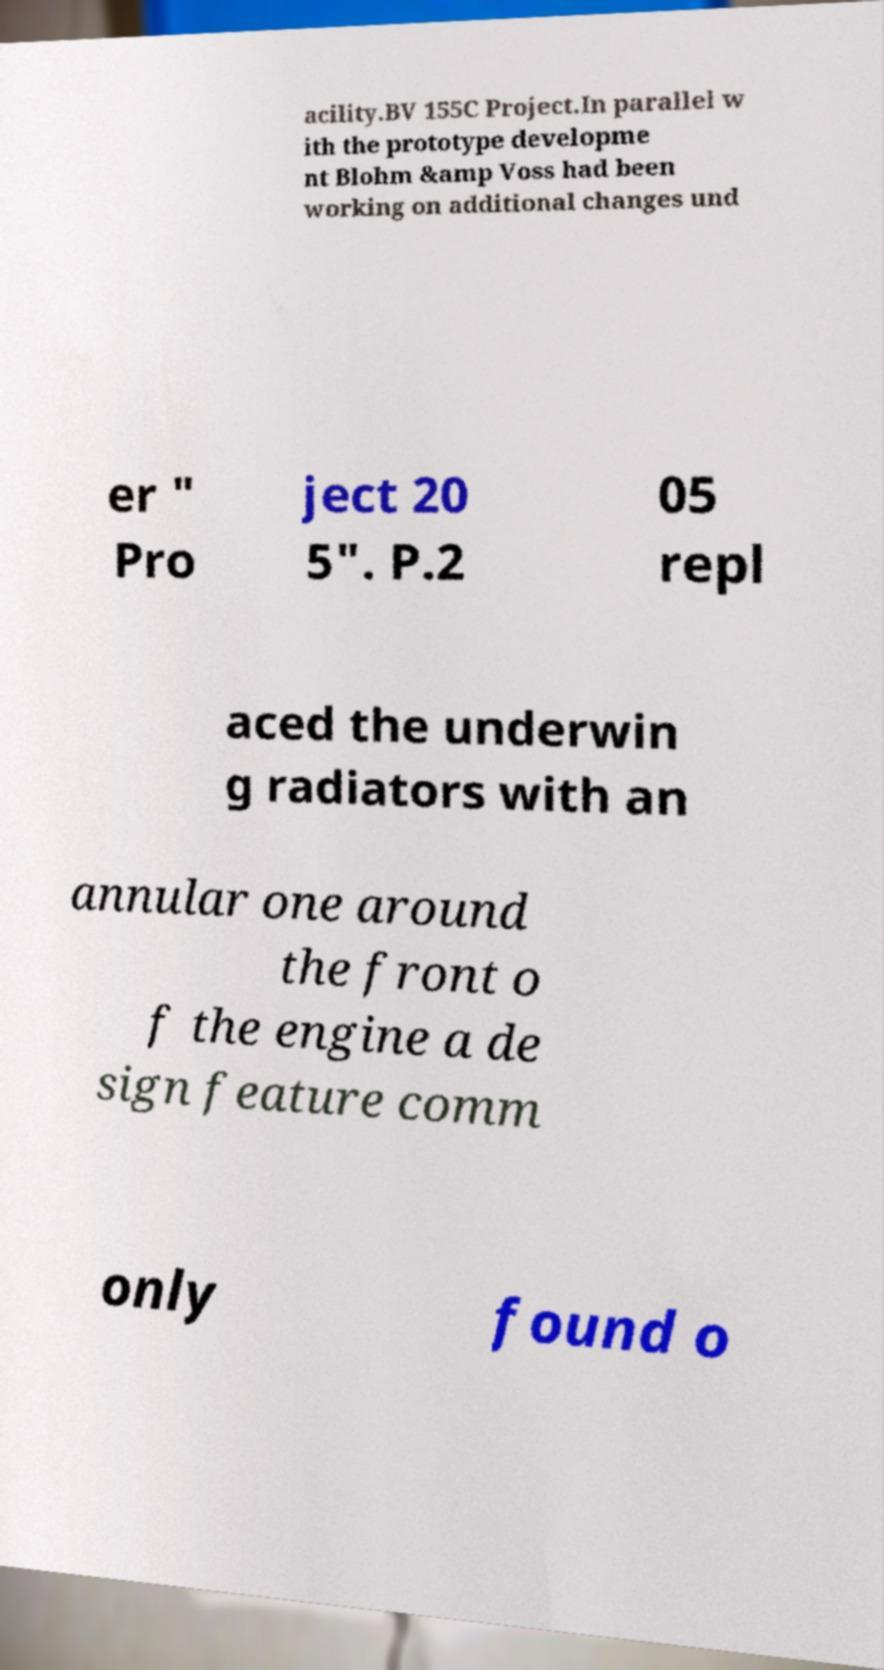There's text embedded in this image that I need extracted. Can you transcribe it verbatim? acility.BV 155C Project.In parallel w ith the prototype developme nt Blohm &amp Voss had been working on additional changes und er " Pro ject 20 5". P.2 05 repl aced the underwin g radiators with an annular one around the front o f the engine a de sign feature comm only found o 